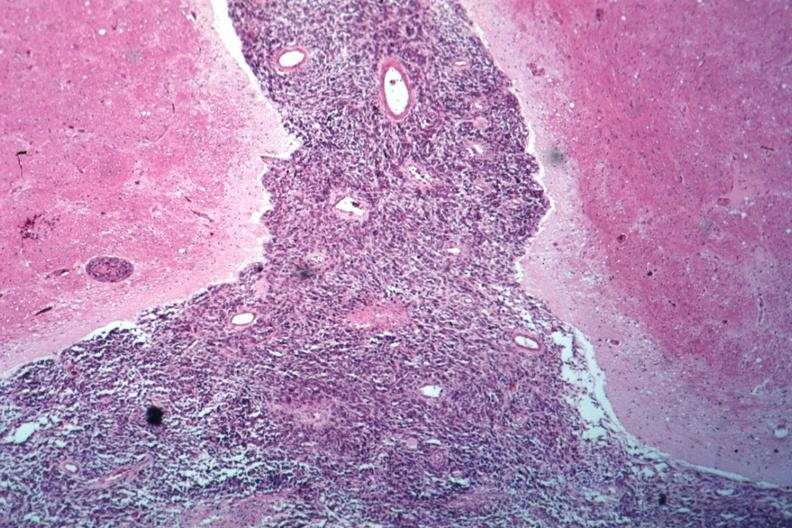does optic nerve show looks like spindle cell tumor filling space well shown primary not known at this time?
Answer the question using a single word or phrase. No 